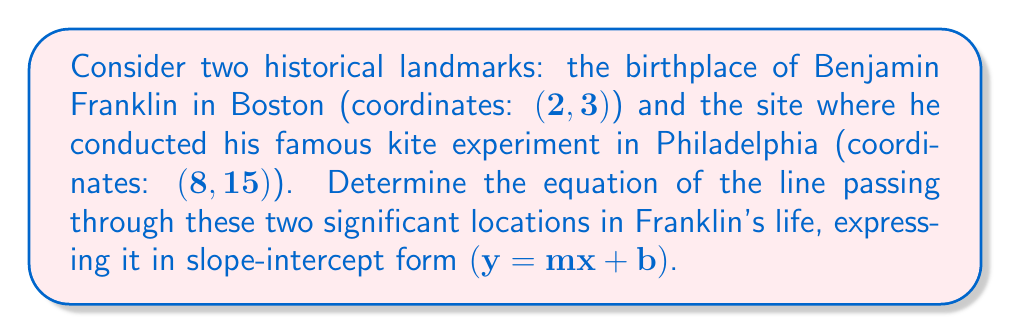Give your solution to this math problem. To find the equation of the line passing through two points, we'll use the point-slope form and then convert it to slope-intercept form. Let's approach this step-by-step:

1) First, we need to calculate the slope of the line. The slope formula is:

   $$m = \frac{y_2 - y_1}{x_2 - x_1}$$

   Where $(x_1, y_1)$ is the first point and $(x_2, y_2)$ is the second point.

2) Substituting our values:
   
   $$m = \frac{15 - 3}{8 - 2} = \frac{12}{6} = 2$$

3) Now that we have the slope, we can use the point-slope form of a line:

   $$y - y_1 = m(x - x_1)$$

   We can use either point. Let's use Franklin's birthplace $(2, 3)$:

   $$y - 3 = 2(x - 2)$$

4) To convert this to slope-intercept form $(y = mx + b)$, we expand the right side:

   $$y - 3 = 2x - 4$$

5) Add 3 to both sides:

   $$y = 2x - 4 + 3$$
   $$y = 2x - 1$$

This is our final equation in slope-intercept form.

[asy]
import graph;
size(200);
xaxis("x", -1, 10, arrow=Arrow);
yaxis("y", -1, 16, arrow=Arrow);
dot((2,3));
dot((8,15));
draw((0,-1)--(10,19), blue);
label("(2,3)", (2,3), SE);
label("(8,15)", (8,15), NW);
[/asy]
Answer: $y = 2x - 1$ 